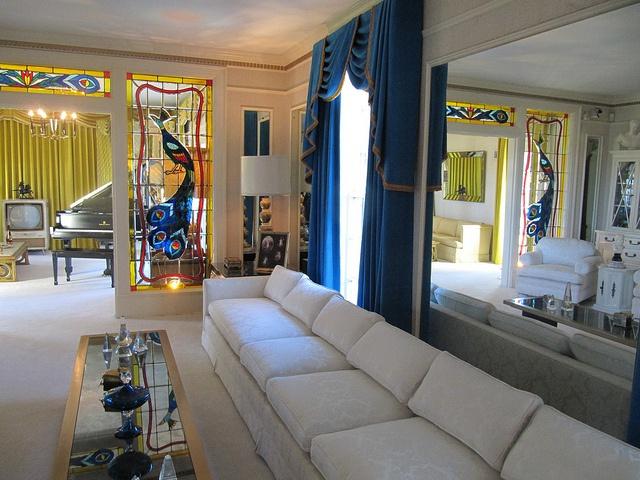Describe the objects in this image and their specific colors. I can see couch in gray tones, dining table in gray and black tones, chair in gray and darkgray tones, tv in gray and darkgray tones, and bird in gray, navy, black, and blue tones in this image. 